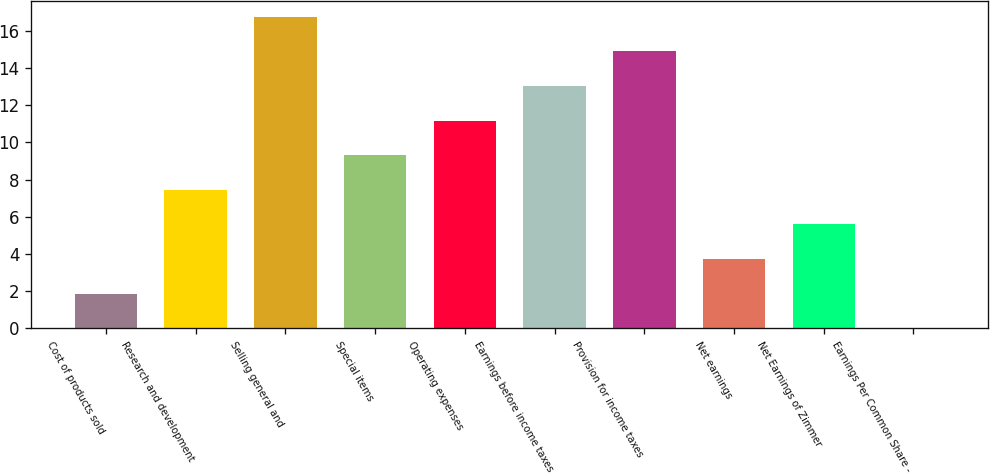Convert chart to OTSL. <chart><loc_0><loc_0><loc_500><loc_500><bar_chart><fcel>Cost of products sold<fcel>Research and development<fcel>Selling general and<fcel>Special items<fcel>Operating expenses<fcel>Earnings before income taxes<fcel>Provision for income taxes<fcel>Net earnings<fcel>Net Earnings of Zimmer<fcel>Earnings Per Common Share -<nl><fcel>1.87<fcel>7.45<fcel>16.75<fcel>9.31<fcel>11.17<fcel>13.03<fcel>14.89<fcel>3.73<fcel>5.59<fcel>0.01<nl></chart> 